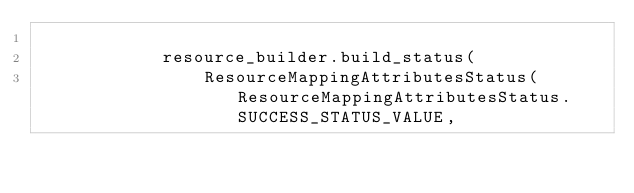Convert code to text. <code><loc_0><loc_0><loc_500><loc_500><_Python_>
            resource_builder.build_status(
                ResourceMappingAttributesStatus(ResourceMappingAttributesStatus.SUCCESS_STATUS_VALUE,</code> 